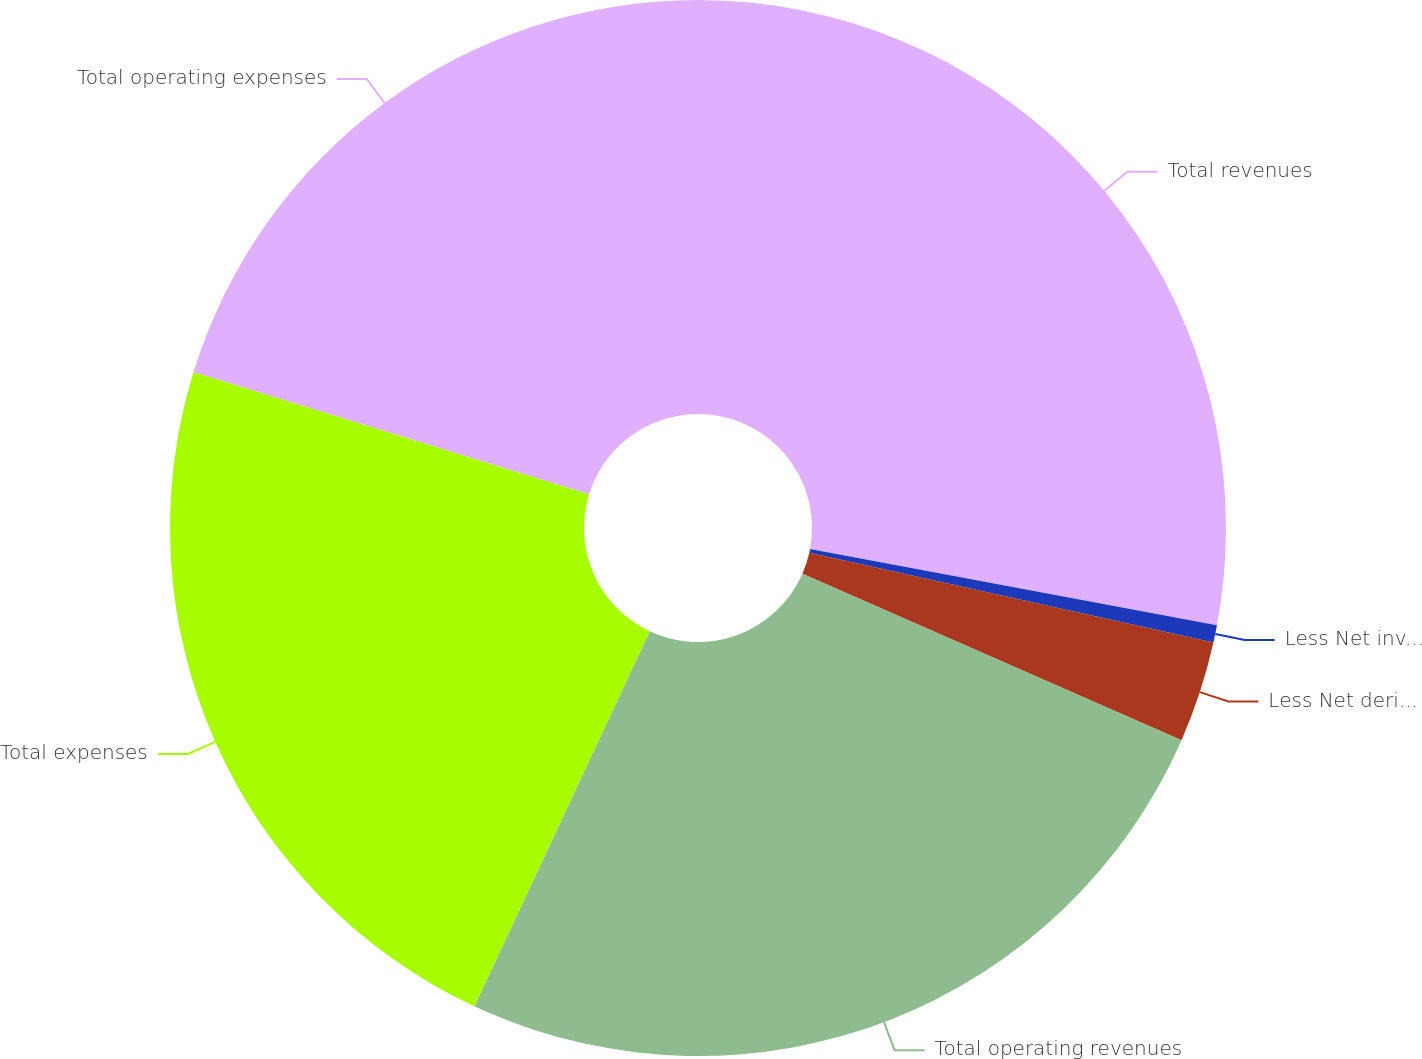Convert chart. <chart><loc_0><loc_0><loc_500><loc_500><pie_chart><fcel>Total revenues<fcel>Less Net investment gains<fcel>Less Net derivative gains<fcel>Total operating revenues<fcel>Total expenses<fcel>Total operating expenses<nl><fcel>27.95%<fcel>0.53%<fcel>3.1%<fcel>25.38%<fcel>22.81%<fcel>20.23%<nl></chart> 